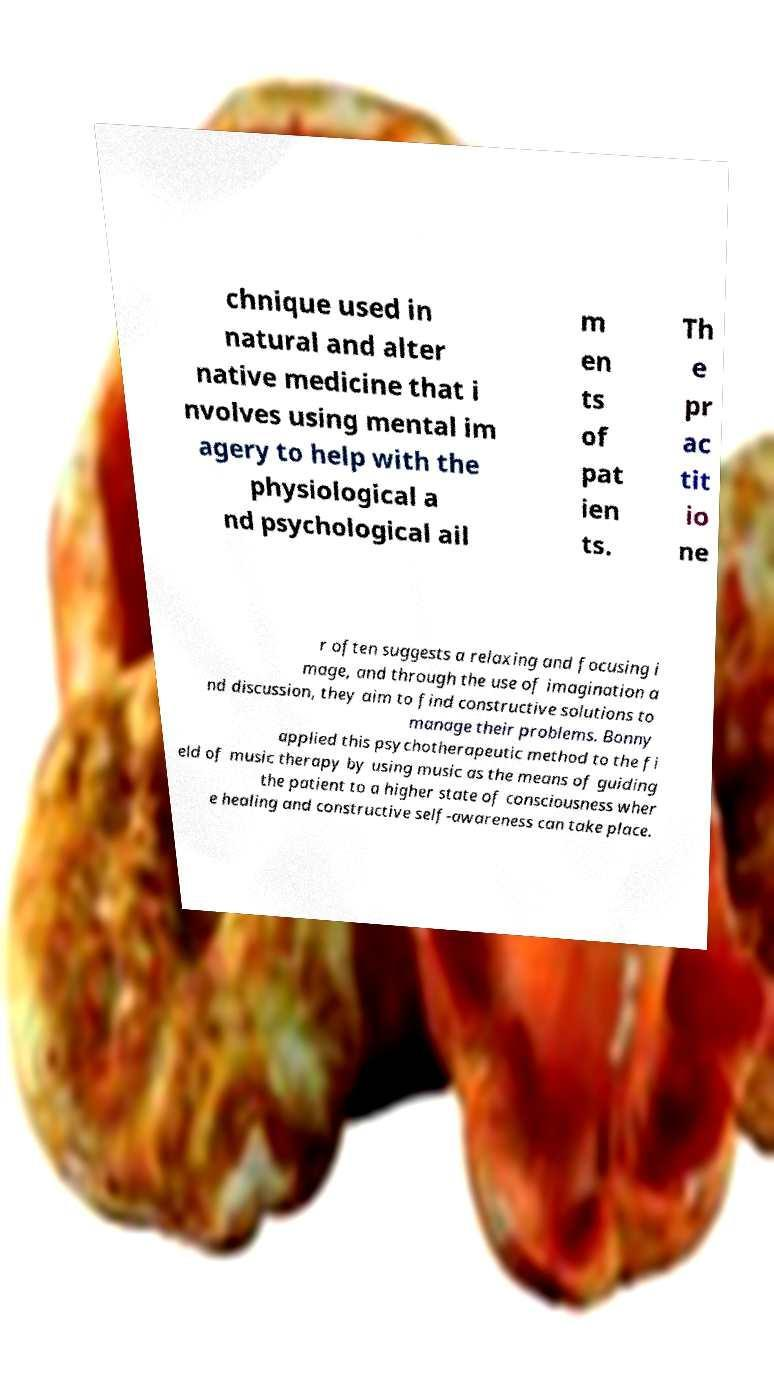Can you read and provide the text displayed in the image?This photo seems to have some interesting text. Can you extract and type it out for me? chnique used in natural and alter native medicine that i nvolves using mental im agery to help with the physiological a nd psychological ail m en ts of pat ien ts. Th e pr ac tit io ne r often suggests a relaxing and focusing i mage, and through the use of imagination a nd discussion, they aim to find constructive solutions to manage their problems. Bonny applied this psychotherapeutic method to the fi eld of music therapy by using music as the means of guiding the patient to a higher state of consciousness wher e healing and constructive self-awareness can take place. 